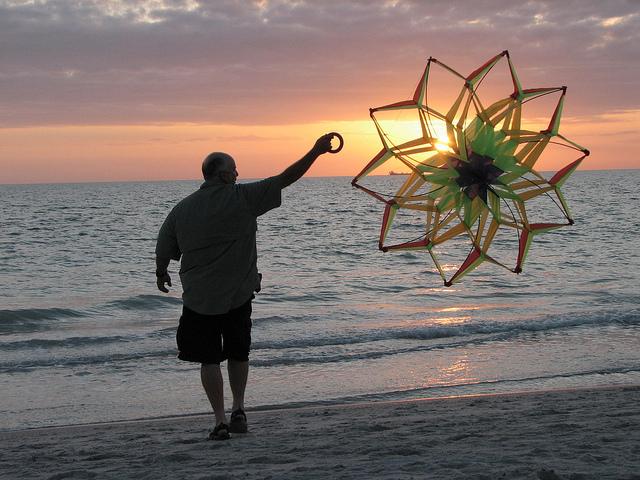Is the man on the sand or in the water?
Concise answer only. Sand. Which hand controls the line?
Quick response, please. Right. What is the man flying?
Answer briefly. Kite. 